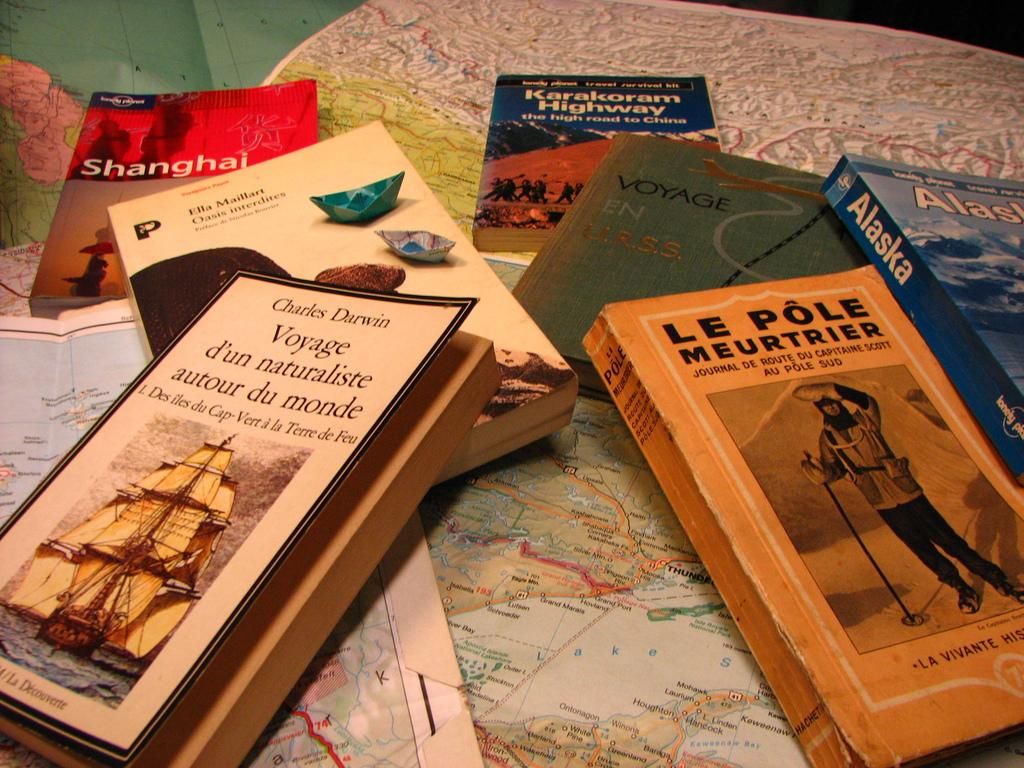<image>
Provide a brief description of the given image. books by other books with one titled 'le pole meurtrier' 